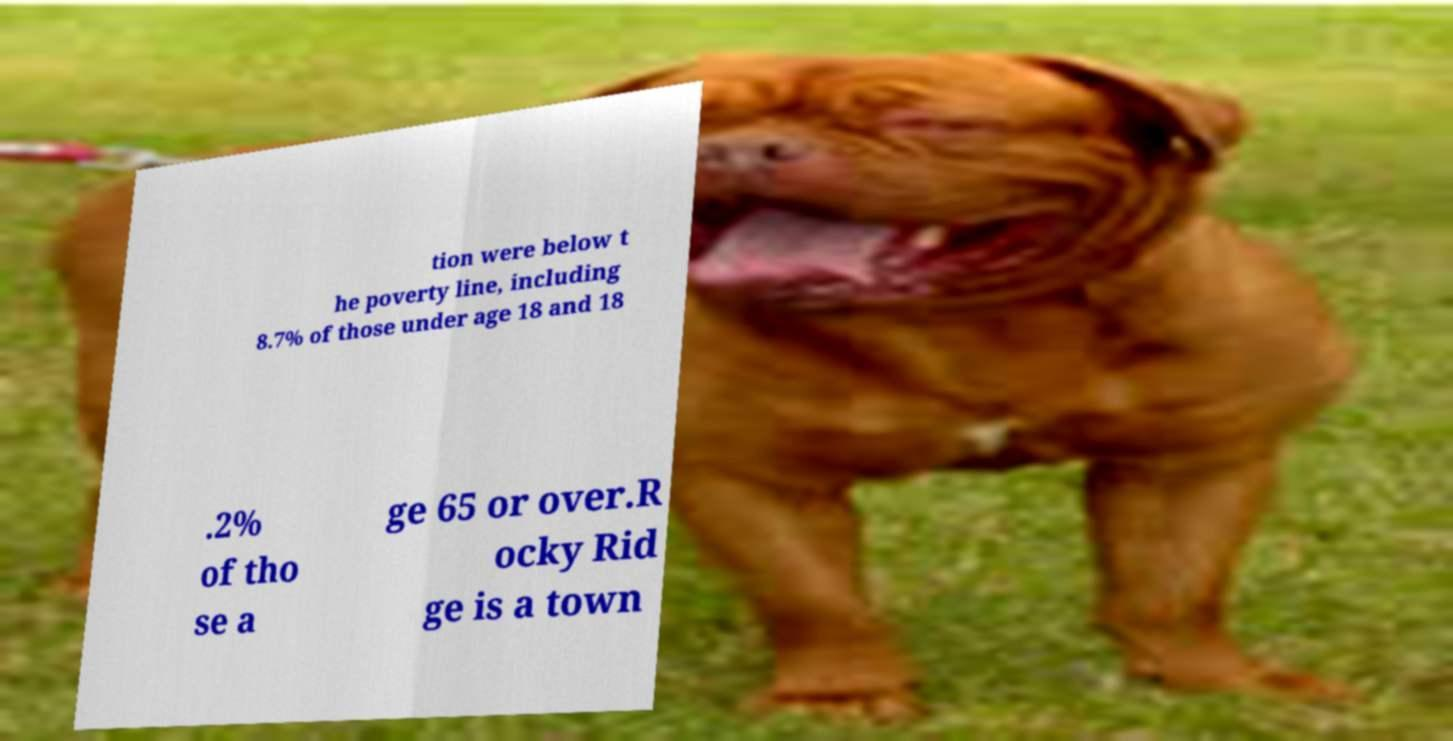I need the written content from this picture converted into text. Can you do that? tion were below t he poverty line, including 8.7% of those under age 18 and 18 .2% of tho se a ge 65 or over.R ocky Rid ge is a town 